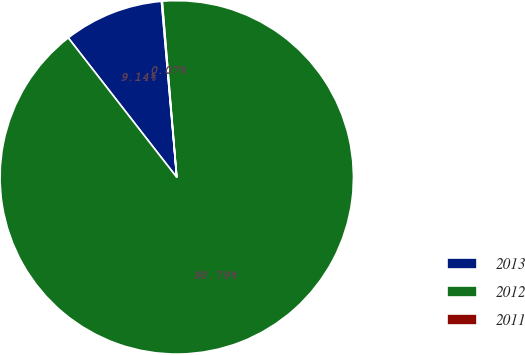<chart> <loc_0><loc_0><loc_500><loc_500><pie_chart><fcel>2013<fcel>2012<fcel>2011<nl><fcel>9.14%<fcel>90.79%<fcel>0.07%<nl></chart> 